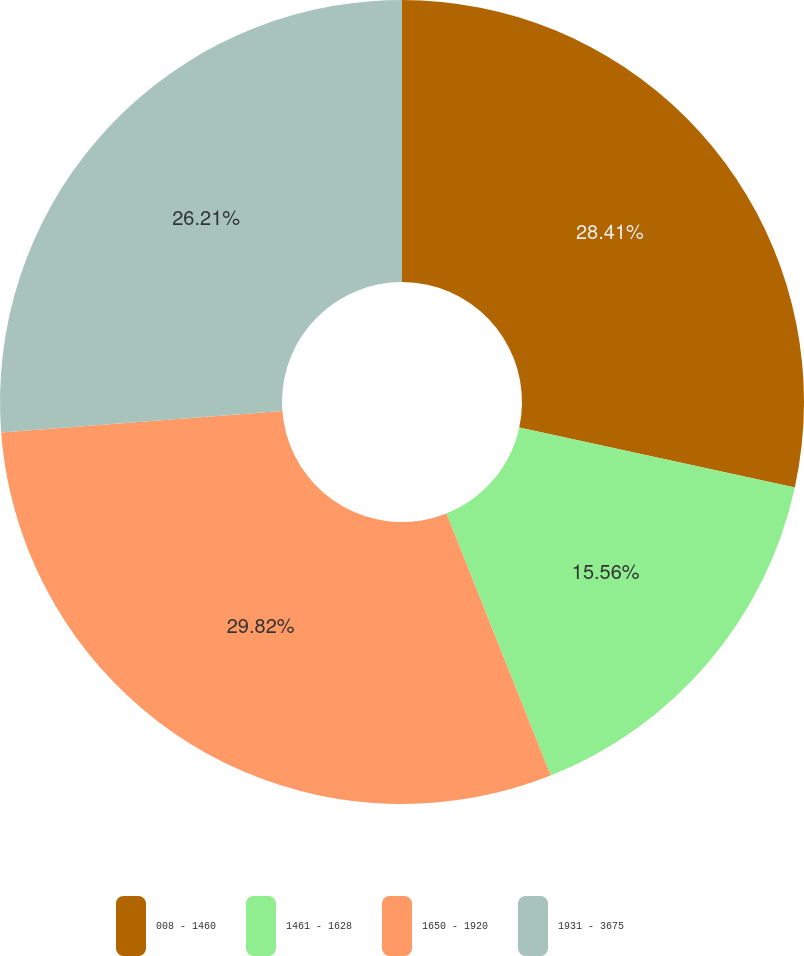Convert chart. <chart><loc_0><loc_0><loc_500><loc_500><pie_chart><fcel>008 - 1460<fcel>1461 - 1628<fcel>1650 - 1920<fcel>1931 - 3675<nl><fcel>28.41%<fcel>15.56%<fcel>29.82%<fcel>26.21%<nl></chart> 